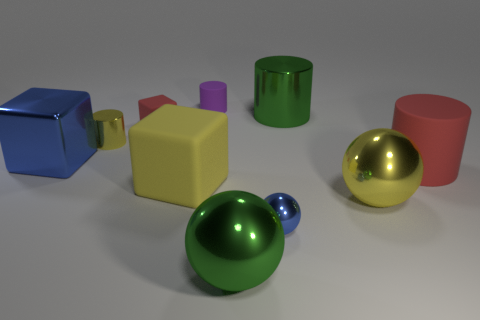Subtract 1 cylinders. How many cylinders are left? 3 Subtract all balls. How many objects are left? 7 Subtract all red cylinders. Subtract all tiny metallic balls. How many objects are left? 8 Add 3 large red objects. How many large red objects are left? 4 Add 2 green metallic cylinders. How many green metallic cylinders exist? 3 Subtract 1 purple cylinders. How many objects are left? 9 